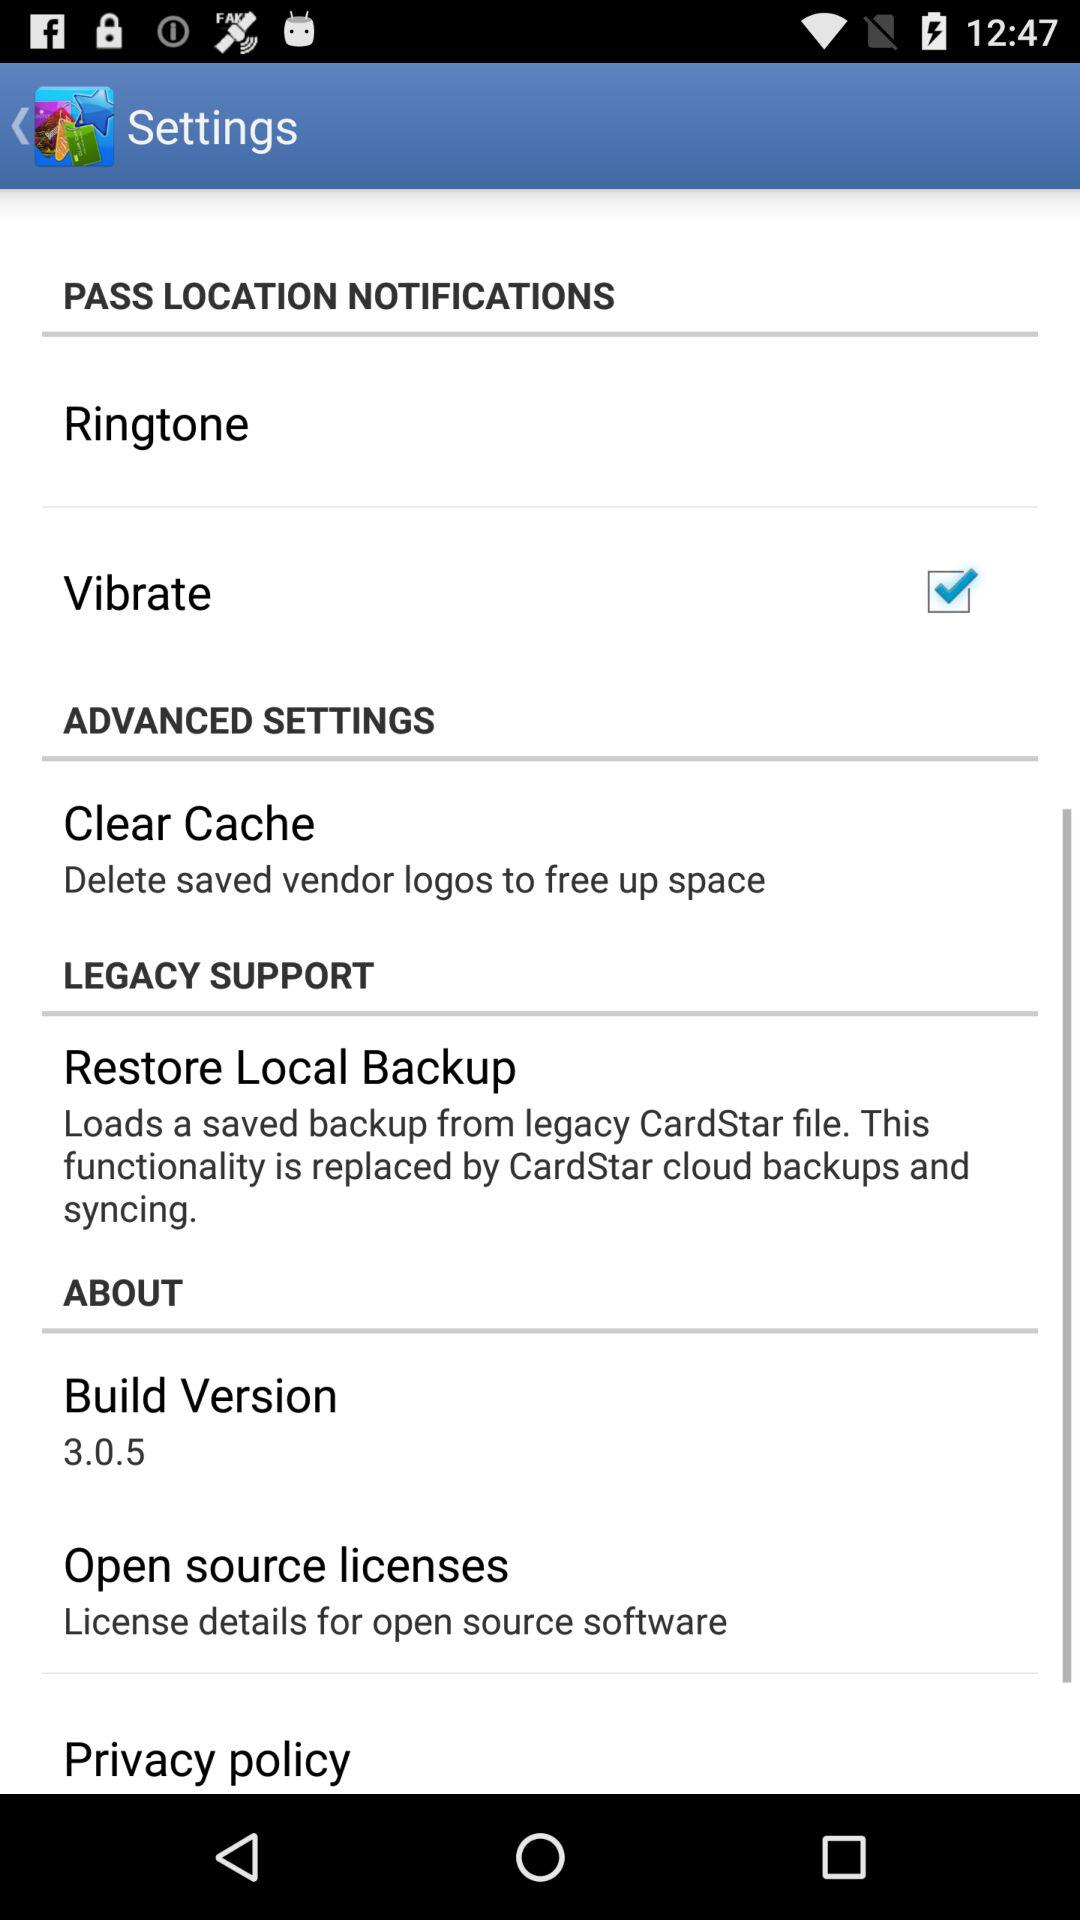What is the status of "Vibrate"? The status of "Vibrate" is "on". 